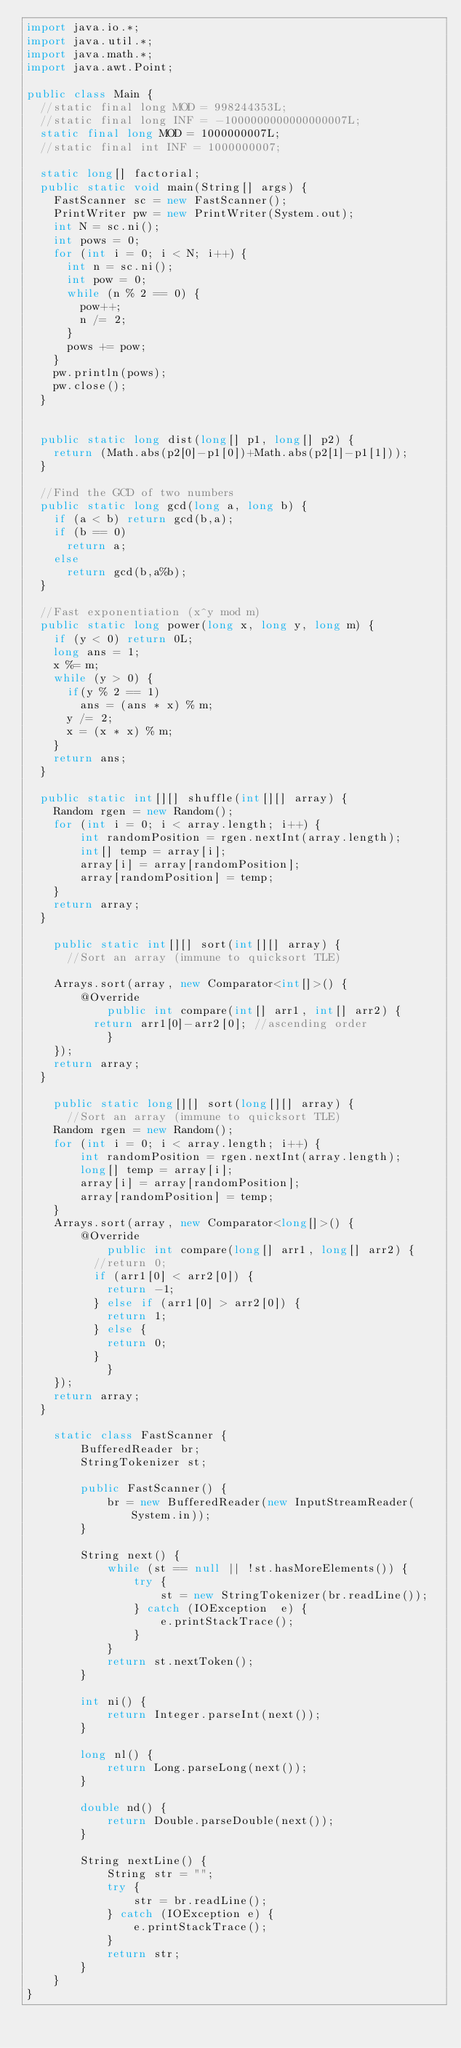<code> <loc_0><loc_0><loc_500><loc_500><_Java_>import java.io.*;
import java.util.*;
import java.math.*;
import java.awt.Point;
 
public class Main {
	//static final long MOD = 998244353L;
	//static final long INF = -1000000000000000007L;
	static final long MOD = 1000000007L;
	//static final int INF = 1000000007;
	
	static long[] factorial;
	public static void main(String[] args) {
		FastScanner sc = new FastScanner();
		PrintWriter pw = new PrintWriter(System.out);
		int N = sc.ni();
		int pows = 0;
		for (int i = 0; i < N; i++) {
			int n = sc.ni();
			int pow = 0;
			while (n % 2 == 0) {
				pow++;
				n /= 2;
			}
			pows += pow;
		}
		pw.println(pows);
		pw.close();
	}

	
	public static long dist(long[] p1, long[] p2) {
		return (Math.abs(p2[0]-p1[0])+Math.abs(p2[1]-p1[1]));
	}
	
	//Find the GCD of two numbers
	public static long gcd(long a, long b) {
		if (a < b) return gcd(b,a);
		if (b == 0)
			return a;
		else
			return gcd(b,a%b);
	}
	
	//Fast exponentiation (x^y mod m)
	public static long power(long x, long y, long m) { 
		if (y < 0) return 0L;
		long ans = 1;
		x %= m;
		while (y > 0) { 
			if(y % 2 == 1) 
				ans = (ans * x) % m; 
			y /= 2;  
			x = (x * x) % m;
		} 
		return ans; 
	}
	
	public static int[][] shuffle(int[][] array) {
		Random rgen = new Random();
		for (int i = 0; i < array.length; i++) {
		    int randomPosition = rgen.nextInt(array.length);
		    int[] temp = array[i];
		    array[i] = array[randomPosition];
		    array[randomPosition] = temp;
		}
		return array;
	}
	
    public static int[][] sort(int[][] array) {
    	//Sort an array (immune to quicksort TLE)
 
		Arrays.sort(array, new Comparator<int[]>() {
			  @Override
        	  public int compare(int[] arr1, int[] arr2) {
				  return arr1[0]-arr2[0]; //ascending order
	          }
		});
		return array;
	}
    
    public static long[][] sort(long[][] array) {
    	//Sort an array (immune to quicksort TLE)
		Random rgen = new Random();
		for (int i = 0; i < array.length; i++) {
		    int randomPosition = rgen.nextInt(array.length);
		    long[] temp = array[i];
		    array[i] = array[randomPosition];
		    array[randomPosition] = temp;
		}
		Arrays.sort(array, new Comparator<long[]>() {
			  @Override
        	  public int compare(long[] arr1, long[] arr2) {
				  //return 0;
				  if (arr1[0] < arr2[0]) {
					  return -1;
				  } else if (arr1[0] > arr2[0]) {
					  return 1;
				  } else {
					  return 0;
				  }
	          }
		});
		return array;
	}
    
    static class FastScanner { 
        BufferedReader br; 
        StringTokenizer st; 
  
        public FastScanner() { 
            br = new BufferedReader(new InputStreamReader(System.in)); 
        } 
  
        String next() { 
            while (st == null || !st.hasMoreElements()) { 
                try { 
                    st = new StringTokenizer(br.readLine());
                } catch (IOException  e) { 
                    e.printStackTrace(); 
                } 
            } 
            return st.nextToken(); 
        } 
  
        int ni() { 
            return Integer.parseInt(next()); 
        } 
  
        long nl() { 
            return Long.parseLong(next()); 
        } 
  
        double nd() { 
            return Double.parseDouble(next()); 
        } 
  
        String nextLine() { 
            String str = ""; 
            try { 
                str = br.readLine(); 
            } catch (IOException e) {
                e.printStackTrace(); 
            } 
            return str;
        }
    }
}</code> 